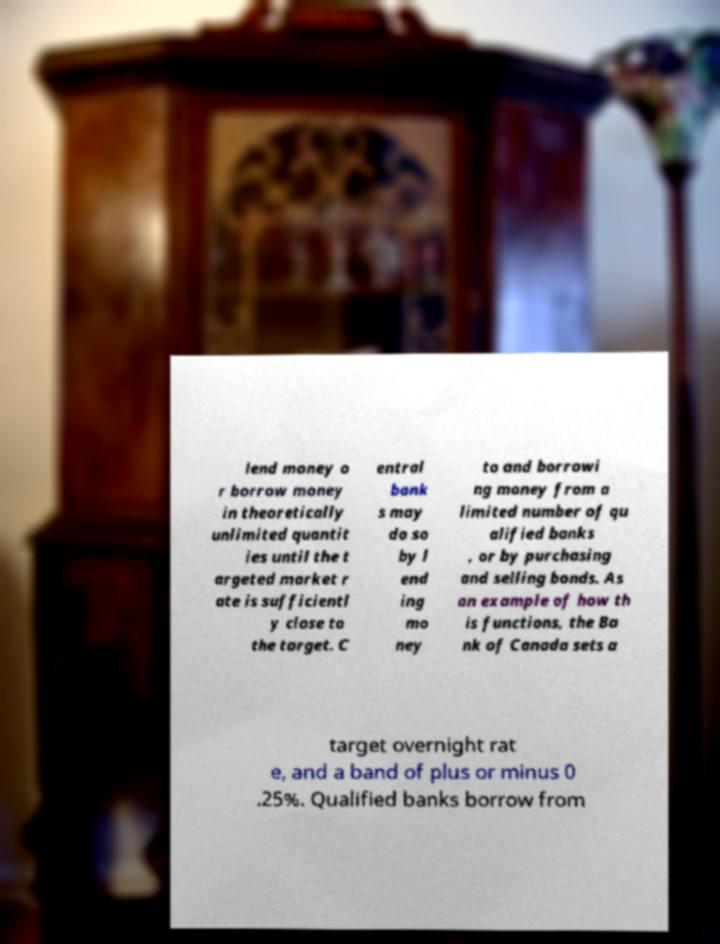What messages or text are displayed in this image? I need them in a readable, typed format. lend money o r borrow money in theoretically unlimited quantit ies until the t argeted market r ate is sufficientl y close to the target. C entral bank s may do so by l end ing mo ney to and borrowi ng money from a limited number of qu alified banks , or by purchasing and selling bonds. As an example of how th is functions, the Ba nk of Canada sets a target overnight rat e, and a band of plus or minus 0 .25%. Qualified banks borrow from 